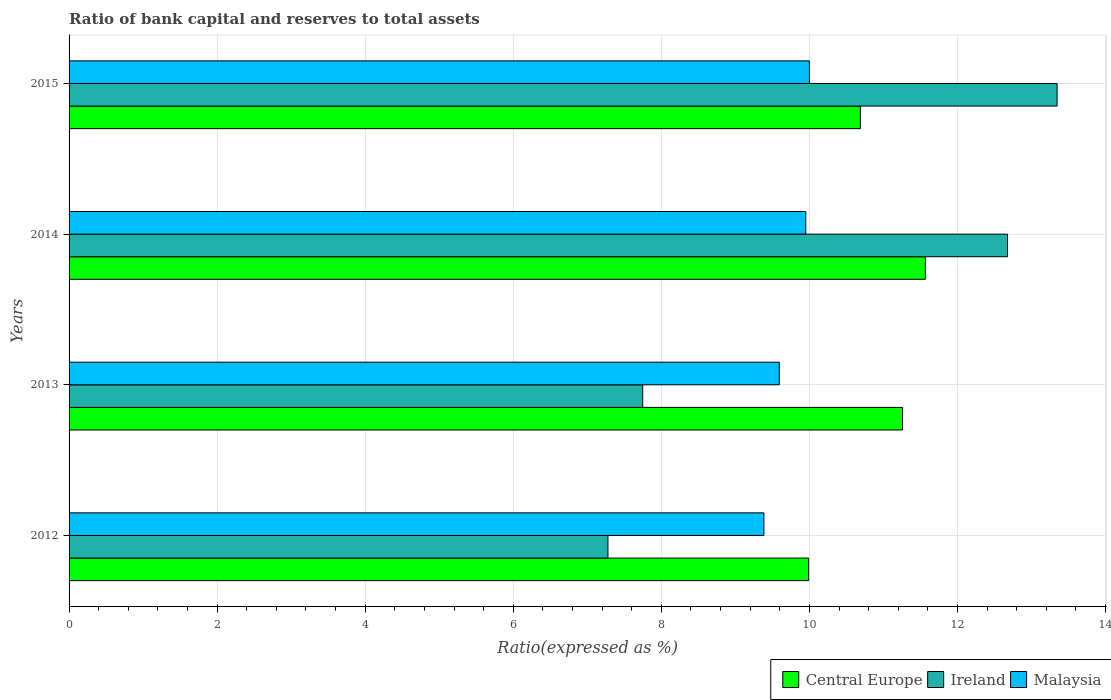How many different coloured bars are there?
Ensure brevity in your answer.  3. How many groups of bars are there?
Ensure brevity in your answer.  4. Are the number of bars per tick equal to the number of legend labels?
Your answer should be compact. Yes. Are the number of bars on each tick of the Y-axis equal?
Your answer should be compact. Yes. How many bars are there on the 2nd tick from the top?
Keep it short and to the point. 3. In how many cases, is the number of bars for a given year not equal to the number of legend labels?
Your answer should be very brief. 0. What is the ratio of bank capital and reserves to total assets in Central Europe in 2013?
Offer a very short reply. 11.26. Across all years, what is the maximum ratio of bank capital and reserves to total assets in Malaysia?
Provide a short and direct response. 10. Across all years, what is the minimum ratio of bank capital and reserves to total assets in Malaysia?
Make the answer very short. 9.39. In which year was the ratio of bank capital and reserves to total assets in Malaysia maximum?
Make the answer very short. 2015. In which year was the ratio of bank capital and reserves to total assets in Ireland minimum?
Ensure brevity in your answer.  2012. What is the total ratio of bank capital and reserves to total assets in Central Europe in the graph?
Offer a very short reply. 43.5. What is the difference between the ratio of bank capital and reserves to total assets in Malaysia in 2012 and that in 2014?
Your answer should be very brief. -0.57. What is the difference between the ratio of bank capital and reserves to total assets in Ireland in 2013 and the ratio of bank capital and reserves to total assets in Central Europe in 2012?
Ensure brevity in your answer.  -2.24. What is the average ratio of bank capital and reserves to total assets in Central Europe per year?
Your answer should be very brief. 10.88. In the year 2014, what is the difference between the ratio of bank capital and reserves to total assets in Ireland and ratio of bank capital and reserves to total assets in Malaysia?
Ensure brevity in your answer.  2.72. In how many years, is the ratio of bank capital and reserves to total assets in Ireland greater than 11.6 %?
Your answer should be compact. 2. What is the ratio of the ratio of bank capital and reserves to total assets in Malaysia in 2012 to that in 2014?
Give a very brief answer. 0.94. What is the difference between the highest and the second highest ratio of bank capital and reserves to total assets in Central Europe?
Make the answer very short. 0.31. What is the difference between the highest and the lowest ratio of bank capital and reserves to total assets in Central Europe?
Provide a succinct answer. 1.58. In how many years, is the ratio of bank capital and reserves to total assets in Ireland greater than the average ratio of bank capital and reserves to total assets in Ireland taken over all years?
Your response must be concise. 2. What does the 1st bar from the top in 2015 represents?
Provide a succinct answer. Malaysia. What does the 3rd bar from the bottom in 2015 represents?
Provide a short and direct response. Malaysia. How many bars are there?
Your answer should be very brief. 12. Are all the bars in the graph horizontal?
Your answer should be very brief. Yes. How many years are there in the graph?
Make the answer very short. 4. What is the difference between two consecutive major ticks on the X-axis?
Provide a short and direct response. 2. Are the values on the major ticks of X-axis written in scientific E-notation?
Your response must be concise. No. Does the graph contain any zero values?
Offer a terse response. No. Does the graph contain grids?
Make the answer very short. Yes. How are the legend labels stacked?
Offer a terse response. Horizontal. What is the title of the graph?
Provide a short and direct response. Ratio of bank capital and reserves to total assets. Does "Greece" appear as one of the legend labels in the graph?
Provide a short and direct response. No. What is the label or title of the X-axis?
Provide a short and direct response. Ratio(expressed as %). What is the label or title of the Y-axis?
Ensure brevity in your answer.  Years. What is the Ratio(expressed as %) in Central Europe in 2012?
Offer a terse response. 9.99. What is the Ratio(expressed as %) in Ireland in 2012?
Give a very brief answer. 7.28. What is the Ratio(expressed as %) of Malaysia in 2012?
Your answer should be very brief. 9.39. What is the Ratio(expressed as %) of Central Europe in 2013?
Give a very brief answer. 11.26. What is the Ratio(expressed as %) in Ireland in 2013?
Provide a short and direct response. 7.75. What is the Ratio(expressed as %) in Malaysia in 2013?
Your response must be concise. 9.59. What is the Ratio(expressed as %) in Central Europe in 2014?
Your answer should be very brief. 11.57. What is the Ratio(expressed as %) of Ireland in 2014?
Your answer should be very brief. 12.68. What is the Ratio(expressed as %) in Malaysia in 2014?
Offer a terse response. 9.95. What is the Ratio(expressed as %) of Central Europe in 2015?
Offer a very short reply. 10.69. What is the Ratio(expressed as %) of Ireland in 2015?
Your answer should be compact. 13.35. What is the Ratio(expressed as %) of Malaysia in 2015?
Keep it short and to the point. 10. Across all years, what is the maximum Ratio(expressed as %) of Central Europe?
Your response must be concise. 11.57. Across all years, what is the maximum Ratio(expressed as %) of Ireland?
Offer a very short reply. 13.35. Across all years, what is the maximum Ratio(expressed as %) of Malaysia?
Your answer should be very brief. 10. Across all years, what is the minimum Ratio(expressed as %) in Central Europe?
Offer a very short reply. 9.99. Across all years, what is the minimum Ratio(expressed as %) of Ireland?
Offer a terse response. 7.28. Across all years, what is the minimum Ratio(expressed as %) of Malaysia?
Provide a succinct answer. 9.39. What is the total Ratio(expressed as %) in Central Europe in the graph?
Offer a very short reply. 43.5. What is the total Ratio(expressed as %) of Ireland in the graph?
Make the answer very short. 41.05. What is the total Ratio(expressed as %) in Malaysia in the graph?
Keep it short and to the point. 38.93. What is the difference between the Ratio(expressed as %) of Central Europe in 2012 and that in 2013?
Offer a very short reply. -1.27. What is the difference between the Ratio(expressed as %) of Ireland in 2012 and that in 2013?
Offer a very short reply. -0.47. What is the difference between the Ratio(expressed as %) in Malaysia in 2012 and that in 2013?
Offer a terse response. -0.21. What is the difference between the Ratio(expressed as %) of Central Europe in 2012 and that in 2014?
Offer a very short reply. -1.58. What is the difference between the Ratio(expressed as %) in Ireland in 2012 and that in 2014?
Your answer should be very brief. -5.4. What is the difference between the Ratio(expressed as %) in Malaysia in 2012 and that in 2014?
Make the answer very short. -0.57. What is the difference between the Ratio(expressed as %) in Central Europe in 2012 and that in 2015?
Your answer should be compact. -0.7. What is the difference between the Ratio(expressed as %) of Ireland in 2012 and that in 2015?
Your response must be concise. -6.07. What is the difference between the Ratio(expressed as %) in Malaysia in 2012 and that in 2015?
Your answer should be very brief. -0.61. What is the difference between the Ratio(expressed as %) of Central Europe in 2013 and that in 2014?
Your answer should be very brief. -0.31. What is the difference between the Ratio(expressed as %) in Ireland in 2013 and that in 2014?
Make the answer very short. -4.93. What is the difference between the Ratio(expressed as %) of Malaysia in 2013 and that in 2014?
Keep it short and to the point. -0.36. What is the difference between the Ratio(expressed as %) in Central Europe in 2013 and that in 2015?
Offer a terse response. 0.57. What is the difference between the Ratio(expressed as %) of Ireland in 2013 and that in 2015?
Offer a very short reply. -5.6. What is the difference between the Ratio(expressed as %) of Malaysia in 2013 and that in 2015?
Provide a short and direct response. -0.41. What is the difference between the Ratio(expressed as %) of Central Europe in 2014 and that in 2015?
Offer a terse response. 0.88. What is the difference between the Ratio(expressed as %) of Ireland in 2014 and that in 2015?
Provide a succinct answer. -0.67. What is the difference between the Ratio(expressed as %) in Malaysia in 2014 and that in 2015?
Offer a terse response. -0.05. What is the difference between the Ratio(expressed as %) of Central Europe in 2012 and the Ratio(expressed as %) of Ireland in 2013?
Make the answer very short. 2.24. What is the difference between the Ratio(expressed as %) in Central Europe in 2012 and the Ratio(expressed as %) in Malaysia in 2013?
Offer a very short reply. 0.4. What is the difference between the Ratio(expressed as %) of Ireland in 2012 and the Ratio(expressed as %) of Malaysia in 2013?
Your answer should be compact. -2.31. What is the difference between the Ratio(expressed as %) in Central Europe in 2012 and the Ratio(expressed as %) in Ireland in 2014?
Ensure brevity in your answer.  -2.69. What is the difference between the Ratio(expressed as %) in Central Europe in 2012 and the Ratio(expressed as %) in Malaysia in 2014?
Provide a succinct answer. 0.04. What is the difference between the Ratio(expressed as %) of Ireland in 2012 and the Ratio(expressed as %) of Malaysia in 2014?
Your answer should be compact. -2.67. What is the difference between the Ratio(expressed as %) of Central Europe in 2012 and the Ratio(expressed as %) of Ireland in 2015?
Keep it short and to the point. -3.36. What is the difference between the Ratio(expressed as %) in Central Europe in 2012 and the Ratio(expressed as %) in Malaysia in 2015?
Your response must be concise. -0.01. What is the difference between the Ratio(expressed as %) of Ireland in 2012 and the Ratio(expressed as %) of Malaysia in 2015?
Provide a short and direct response. -2.72. What is the difference between the Ratio(expressed as %) in Central Europe in 2013 and the Ratio(expressed as %) in Ireland in 2014?
Offer a very short reply. -1.42. What is the difference between the Ratio(expressed as %) of Central Europe in 2013 and the Ratio(expressed as %) of Malaysia in 2014?
Your answer should be compact. 1.31. What is the difference between the Ratio(expressed as %) in Ireland in 2013 and the Ratio(expressed as %) in Malaysia in 2014?
Provide a short and direct response. -2.2. What is the difference between the Ratio(expressed as %) in Central Europe in 2013 and the Ratio(expressed as %) in Ireland in 2015?
Make the answer very short. -2.09. What is the difference between the Ratio(expressed as %) of Central Europe in 2013 and the Ratio(expressed as %) of Malaysia in 2015?
Provide a succinct answer. 1.26. What is the difference between the Ratio(expressed as %) in Ireland in 2013 and the Ratio(expressed as %) in Malaysia in 2015?
Offer a very short reply. -2.25. What is the difference between the Ratio(expressed as %) of Central Europe in 2014 and the Ratio(expressed as %) of Ireland in 2015?
Provide a succinct answer. -1.78. What is the difference between the Ratio(expressed as %) of Central Europe in 2014 and the Ratio(expressed as %) of Malaysia in 2015?
Your answer should be compact. 1.57. What is the difference between the Ratio(expressed as %) in Ireland in 2014 and the Ratio(expressed as %) in Malaysia in 2015?
Offer a terse response. 2.68. What is the average Ratio(expressed as %) of Central Europe per year?
Offer a terse response. 10.88. What is the average Ratio(expressed as %) in Ireland per year?
Offer a very short reply. 10.26. What is the average Ratio(expressed as %) of Malaysia per year?
Provide a short and direct response. 9.73. In the year 2012, what is the difference between the Ratio(expressed as %) of Central Europe and Ratio(expressed as %) of Ireland?
Your answer should be compact. 2.71. In the year 2012, what is the difference between the Ratio(expressed as %) of Central Europe and Ratio(expressed as %) of Malaysia?
Your response must be concise. 0.6. In the year 2012, what is the difference between the Ratio(expressed as %) in Ireland and Ratio(expressed as %) in Malaysia?
Your answer should be very brief. -2.11. In the year 2013, what is the difference between the Ratio(expressed as %) of Central Europe and Ratio(expressed as %) of Ireland?
Provide a short and direct response. 3.51. In the year 2013, what is the difference between the Ratio(expressed as %) of Central Europe and Ratio(expressed as %) of Malaysia?
Give a very brief answer. 1.66. In the year 2013, what is the difference between the Ratio(expressed as %) of Ireland and Ratio(expressed as %) of Malaysia?
Offer a very short reply. -1.84. In the year 2014, what is the difference between the Ratio(expressed as %) in Central Europe and Ratio(expressed as %) in Ireland?
Make the answer very short. -1.11. In the year 2014, what is the difference between the Ratio(expressed as %) in Central Europe and Ratio(expressed as %) in Malaysia?
Offer a very short reply. 1.62. In the year 2014, what is the difference between the Ratio(expressed as %) in Ireland and Ratio(expressed as %) in Malaysia?
Give a very brief answer. 2.72. In the year 2015, what is the difference between the Ratio(expressed as %) in Central Europe and Ratio(expressed as %) in Ireland?
Make the answer very short. -2.66. In the year 2015, what is the difference between the Ratio(expressed as %) of Central Europe and Ratio(expressed as %) of Malaysia?
Provide a short and direct response. 0.69. In the year 2015, what is the difference between the Ratio(expressed as %) of Ireland and Ratio(expressed as %) of Malaysia?
Give a very brief answer. 3.35. What is the ratio of the Ratio(expressed as %) in Central Europe in 2012 to that in 2013?
Your answer should be very brief. 0.89. What is the ratio of the Ratio(expressed as %) in Ireland in 2012 to that in 2013?
Make the answer very short. 0.94. What is the ratio of the Ratio(expressed as %) of Malaysia in 2012 to that in 2013?
Provide a short and direct response. 0.98. What is the ratio of the Ratio(expressed as %) of Central Europe in 2012 to that in 2014?
Your response must be concise. 0.86. What is the ratio of the Ratio(expressed as %) in Ireland in 2012 to that in 2014?
Ensure brevity in your answer.  0.57. What is the ratio of the Ratio(expressed as %) in Malaysia in 2012 to that in 2014?
Give a very brief answer. 0.94. What is the ratio of the Ratio(expressed as %) in Central Europe in 2012 to that in 2015?
Offer a very short reply. 0.93. What is the ratio of the Ratio(expressed as %) of Ireland in 2012 to that in 2015?
Ensure brevity in your answer.  0.55. What is the ratio of the Ratio(expressed as %) in Malaysia in 2012 to that in 2015?
Your response must be concise. 0.94. What is the ratio of the Ratio(expressed as %) in Central Europe in 2013 to that in 2014?
Offer a terse response. 0.97. What is the ratio of the Ratio(expressed as %) of Ireland in 2013 to that in 2014?
Your answer should be very brief. 0.61. What is the ratio of the Ratio(expressed as %) in Malaysia in 2013 to that in 2014?
Give a very brief answer. 0.96. What is the ratio of the Ratio(expressed as %) in Central Europe in 2013 to that in 2015?
Offer a very short reply. 1.05. What is the ratio of the Ratio(expressed as %) of Ireland in 2013 to that in 2015?
Keep it short and to the point. 0.58. What is the ratio of the Ratio(expressed as %) of Malaysia in 2013 to that in 2015?
Provide a short and direct response. 0.96. What is the ratio of the Ratio(expressed as %) in Central Europe in 2014 to that in 2015?
Your answer should be compact. 1.08. What is the ratio of the Ratio(expressed as %) of Ireland in 2014 to that in 2015?
Offer a very short reply. 0.95. What is the difference between the highest and the second highest Ratio(expressed as %) in Central Europe?
Provide a succinct answer. 0.31. What is the difference between the highest and the second highest Ratio(expressed as %) in Ireland?
Your answer should be very brief. 0.67. What is the difference between the highest and the second highest Ratio(expressed as %) in Malaysia?
Offer a very short reply. 0.05. What is the difference between the highest and the lowest Ratio(expressed as %) in Central Europe?
Keep it short and to the point. 1.58. What is the difference between the highest and the lowest Ratio(expressed as %) of Ireland?
Your answer should be compact. 6.07. What is the difference between the highest and the lowest Ratio(expressed as %) of Malaysia?
Provide a succinct answer. 0.61. 